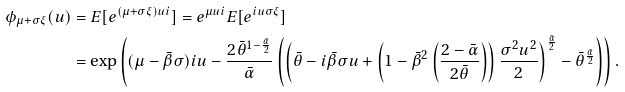Convert formula to latex. <formula><loc_0><loc_0><loc_500><loc_500>\phi _ { \mu + \sigma \xi } ( u ) & = E [ e ^ { ( \mu + \sigma \xi ) u i } ] = e ^ { \mu u i } E [ e ^ { i u \sigma \xi } ] \\ & = \exp \left ( ( \mu - \bar { \beta } \sigma ) i u - \frac { 2 \bar { \theta } ^ { 1 - \frac { \bar { \alpha } } { 2 } } } { \bar { \alpha } } \left ( \left ( \bar { \theta } - i \bar { \beta } \sigma u + \left ( 1 - \bar { \beta } ^ { 2 } \left ( \frac { 2 - \bar { \alpha } } { 2 \bar { \theta } } \right ) \right ) \frac { \sigma ^ { 2 } u ^ { 2 } } { 2 } \right ) ^ { \frac { \bar { \alpha } } { 2 } } - \bar { \theta } ^ { \frac { \bar { \alpha } } { 2 } } \right ) \right ) .</formula> 